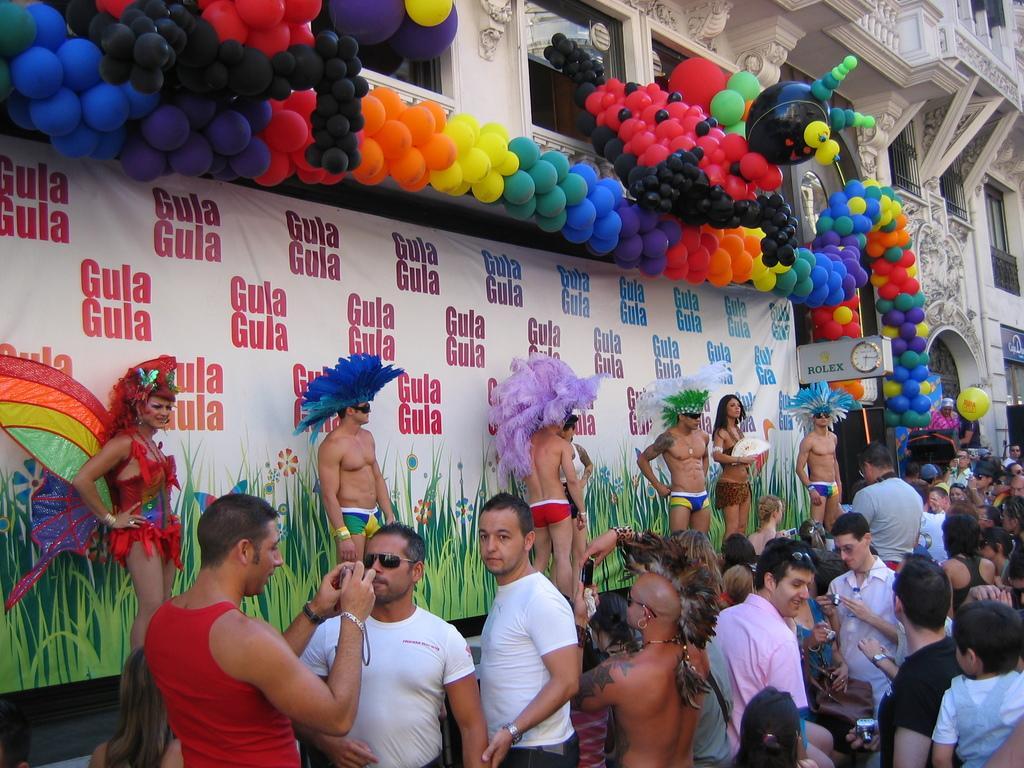Describe this image in one or two sentences. In this image we can see the people standing on the ground and holding objects. And at the back we can see the building with windows and grille. There is a banner with text and balloons attached to the wall. 